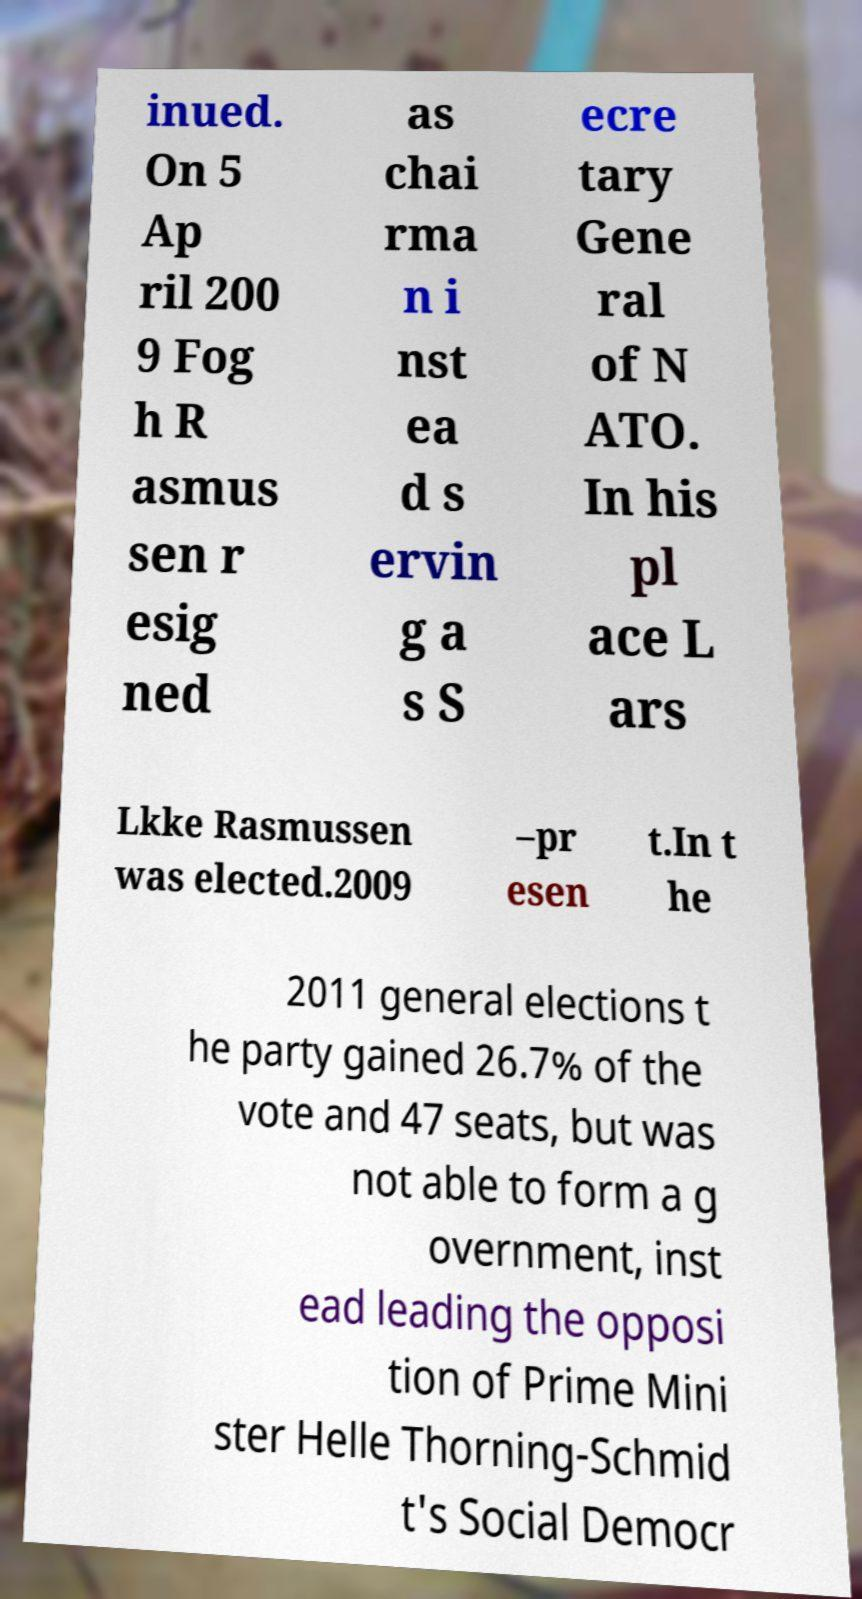What messages or text are displayed in this image? I need them in a readable, typed format. inued. On 5 Ap ril 200 9 Fog h R asmus sen r esig ned as chai rma n i nst ea d s ervin g a s S ecre tary Gene ral of N ATO. In his pl ace L ars Lkke Rasmussen was elected.2009 –pr esen t.In t he 2011 general elections t he party gained 26.7% of the vote and 47 seats, but was not able to form a g overnment, inst ead leading the opposi tion of Prime Mini ster Helle Thorning-Schmid t's Social Democr 